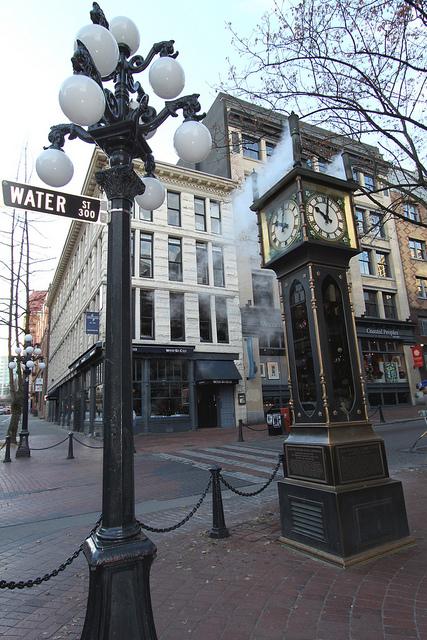How many street signs are there?
Short answer required. 1. What is the name of the street?
Write a very short answer. Water. Is it daytime?
Concise answer only. Yes. Is this a fire hydrant?
Keep it brief. No. What time is it on the clock?
Give a very brief answer. 10:00. 